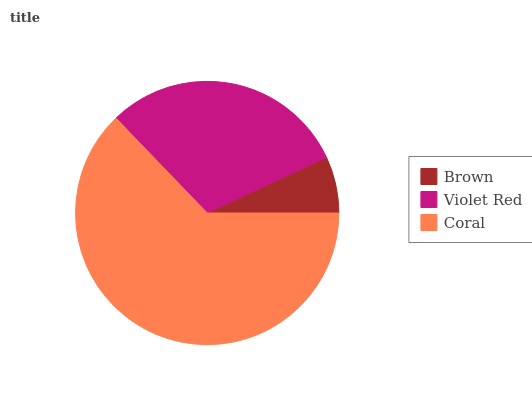Is Brown the minimum?
Answer yes or no. Yes. Is Coral the maximum?
Answer yes or no. Yes. Is Violet Red the minimum?
Answer yes or no. No. Is Violet Red the maximum?
Answer yes or no. No. Is Violet Red greater than Brown?
Answer yes or no. Yes. Is Brown less than Violet Red?
Answer yes or no. Yes. Is Brown greater than Violet Red?
Answer yes or no. No. Is Violet Red less than Brown?
Answer yes or no. No. Is Violet Red the high median?
Answer yes or no. Yes. Is Violet Red the low median?
Answer yes or no. Yes. Is Brown the high median?
Answer yes or no. No. Is Coral the low median?
Answer yes or no. No. 